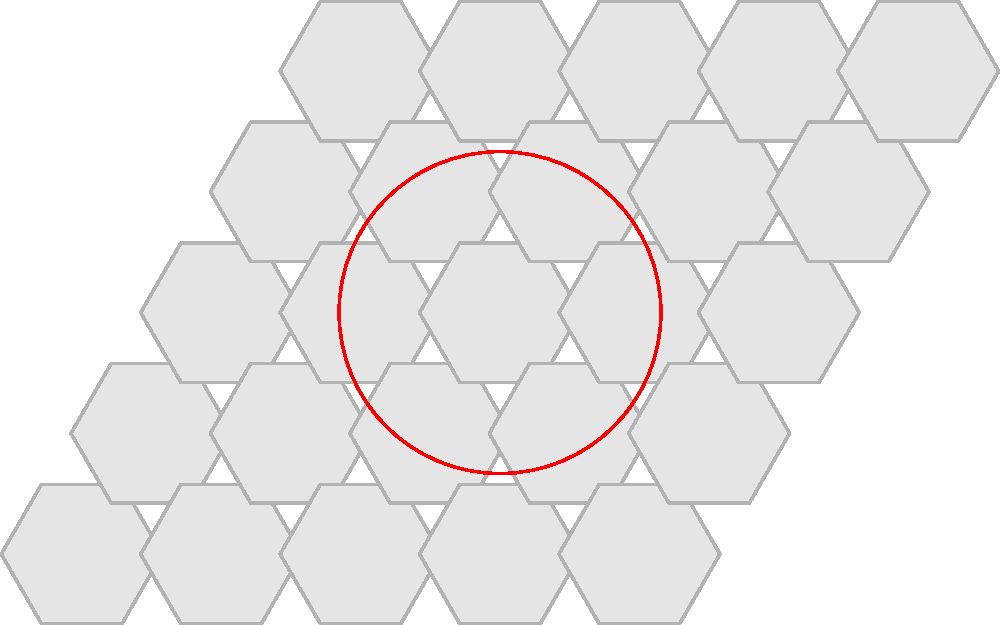You want to tile the floor of your tea house using hexagonal tiles. If each hexagonal tile has a side length of 20 cm, and you need to cover a circular area with a radius of 2 meters, approximately how many whole tiles will you need? Let's approach this step-by-step:

1) First, we need to calculate the area of the circular floor:
   Area of circle = $\pi r^2$ = $\pi (2\text{ m})^2$ = $4\pi \text{ m}^2$ = $12.57 \text{ m}^2$

2) Next, we need to calculate the area of each hexagonal tile:
   Area of hexagon = $\frac{3\sqrt{3}}{2}s^2$, where $s$ is the side length
   $s = 20 \text{ cm} = 0.2 \text{ m}$
   Area of hexagon = $\frac{3\sqrt{3}}{2}(0.2\text{ m})^2$ = $0.1039 \text{ m}^2$

3) Now, we can divide the area of the circle by the area of each hexagon:
   Number of tiles = $\frac{12.57 \text{ m}^2}{0.1039 \text{ m}^2}$ = 120.98

4) However, we need to consider that we can't use partial tiles, and there will be some waste around the edges of the circle. Therefore, we should round up to the next whole number and add a few extra tiles for the edges.

5) A good estimate would be to round up to 125 tiles, which allows for some extra tiles to cover the circular edge.
Answer: Approximately 125 tiles 